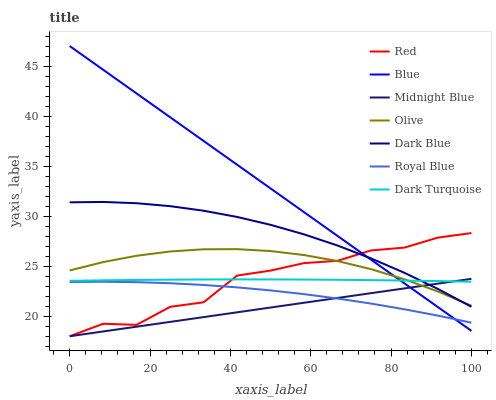Does Midnight Blue have the minimum area under the curve?
Answer yes or no. Yes. Does Blue have the maximum area under the curve?
Answer yes or no. Yes. Does Dark Blue have the minimum area under the curve?
Answer yes or no. No. Does Dark Blue have the maximum area under the curve?
Answer yes or no. No. Is Midnight Blue the smoothest?
Answer yes or no. Yes. Is Red the roughest?
Answer yes or no. Yes. Is Dark Blue the smoothest?
Answer yes or no. No. Is Dark Blue the roughest?
Answer yes or no. No. Does Midnight Blue have the lowest value?
Answer yes or no. Yes. Does Dark Blue have the lowest value?
Answer yes or no. No. Does Blue have the highest value?
Answer yes or no. Yes. Does Midnight Blue have the highest value?
Answer yes or no. No. Is Royal Blue less than Olive?
Answer yes or no. Yes. Is Dark Blue greater than Royal Blue?
Answer yes or no. Yes. Does Blue intersect Royal Blue?
Answer yes or no. Yes. Is Blue less than Royal Blue?
Answer yes or no. No. Is Blue greater than Royal Blue?
Answer yes or no. No. Does Royal Blue intersect Olive?
Answer yes or no. No. 